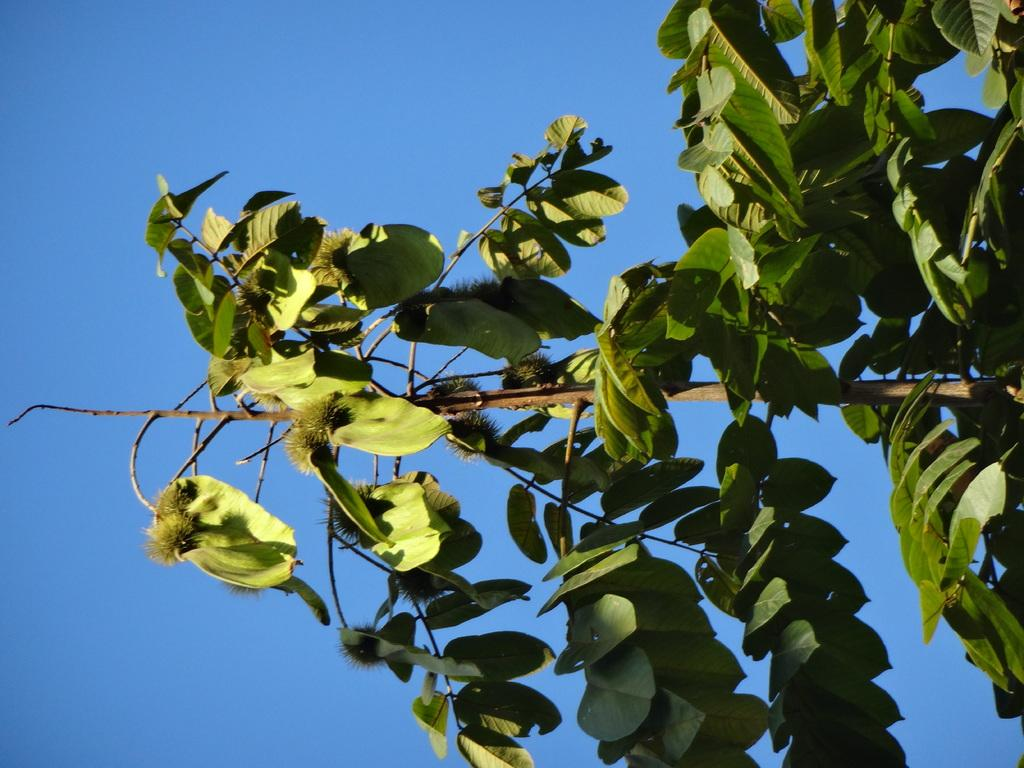What type of plant can be seen in the image? There is a tree in the image. What part of the natural environment is visible in the image? The sky is visible in the image. What type of protest is taking place near the tree in the image? There is no protest present in the image; it only features a tree and the sky. Can you tell me what kind of pet is sitting next to the tree in the image? There is no pet present in the image; it only features a tree and the sky. Where is the mailbox located in the image? There is no mailbox present in the image; it only features a tree and the sky. 